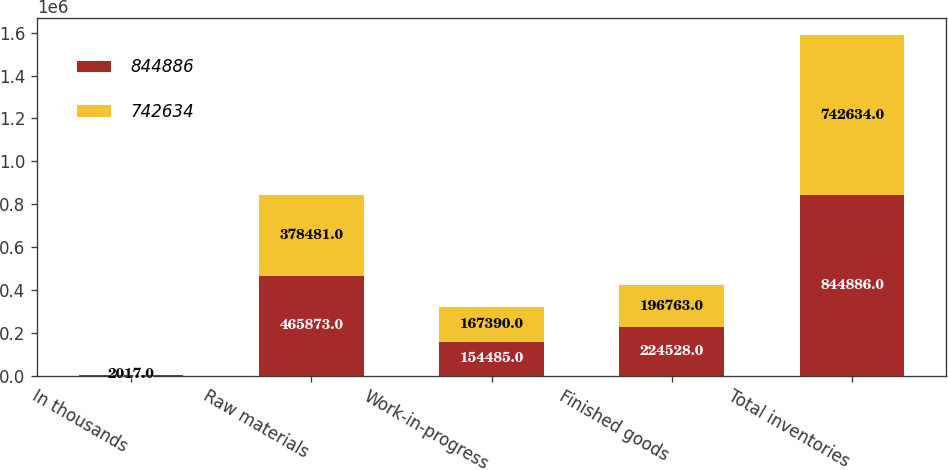Convert chart to OTSL. <chart><loc_0><loc_0><loc_500><loc_500><stacked_bar_chart><ecel><fcel>In thousands<fcel>Raw materials<fcel>Work-in-progress<fcel>Finished goods<fcel>Total inventories<nl><fcel>844886<fcel>2018<fcel>465873<fcel>154485<fcel>224528<fcel>844886<nl><fcel>742634<fcel>2017<fcel>378481<fcel>167390<fcel>196763<fcel>742634<nl></chart> 